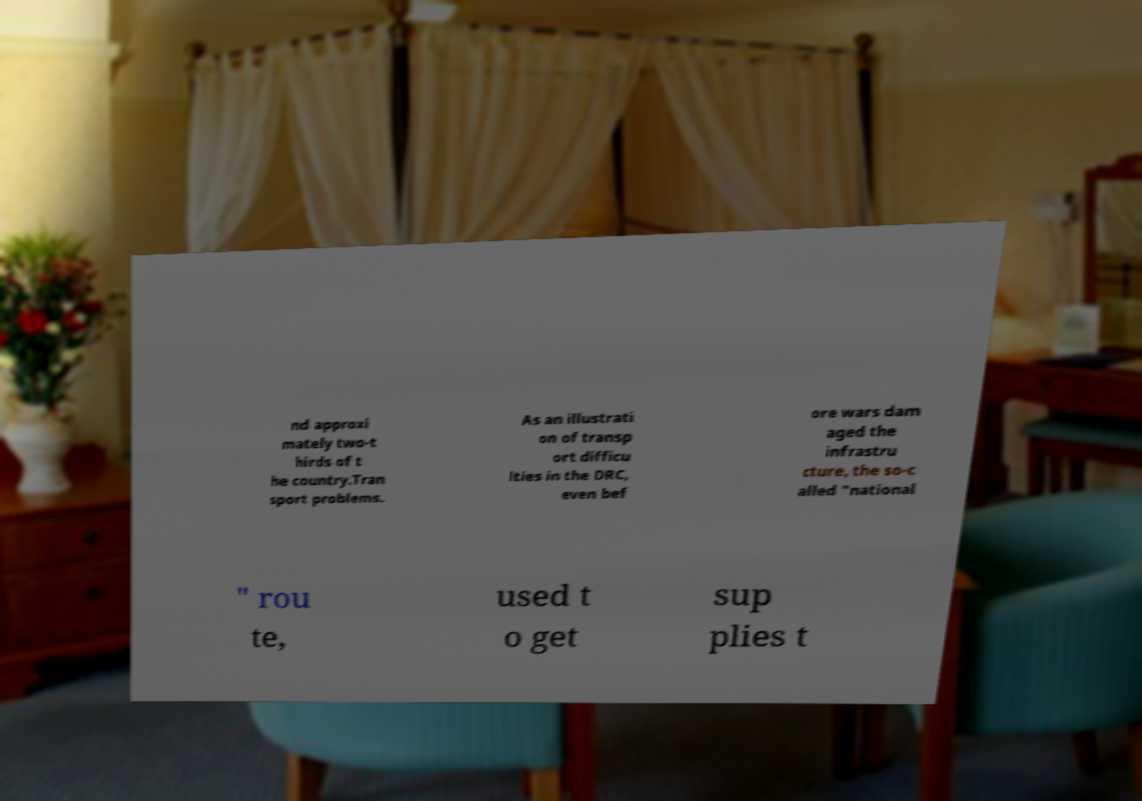Please identify and transcribe the text found in this image. nd approxi mately two-t hirds of t he country.Tran sport problems. As an illustrati on of transp ort difficu lties in the DRC, even bef ore wars dam aged the infrastru cture, the so-c alled "national " rou te, used t o get sup plies t 